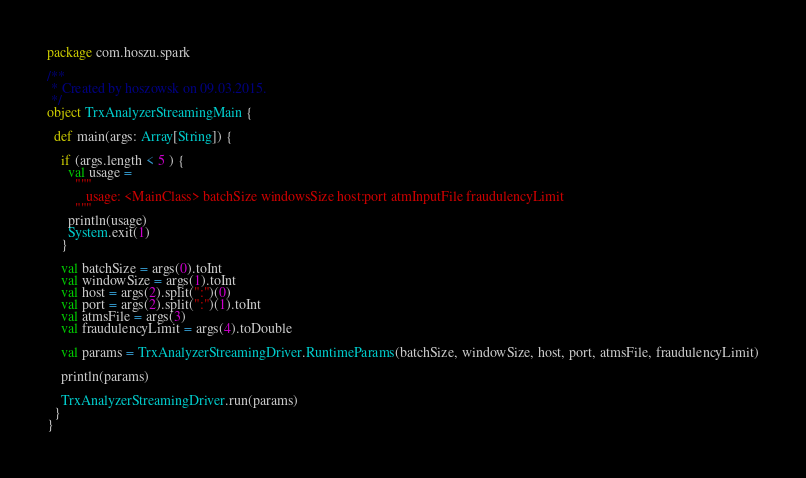Convert code to text. <code><loc_0><loc_0><loc_500><loc_500><_Scala_>package com.hoszu.spark

/**
 * Created by hoszowsk on 09.03.2015.
 */
object TrxAnalyzerStreamingMain {

  def main(args: Array[String]) {

    if (args.length < 5 ) {
      val usage =
        """
           usage: <MainClass> batchSize windowsSize host:port atmInputFile fraudulencyLimit
        """
      println(usage)
      System.exit(1)
    }

    val batchSize = args(0).toInt
    val windowSize = args(1).toInt
    val host = args(2).split(":")(0)
    val port = args(2).split(":")(1).toInt
    val atmsFile = args(3)
    val fraudulencyLimit = args(4).toDouble

    val params = TrxAnalyzerStreamingDriver.RuntimeParams(batchSize, windowSize, host, port, atmsFile, fraudulencyLimit)

    println(params)

    TrxAnalyzerStreamingDriver.run(params)
  }
}
</code> 